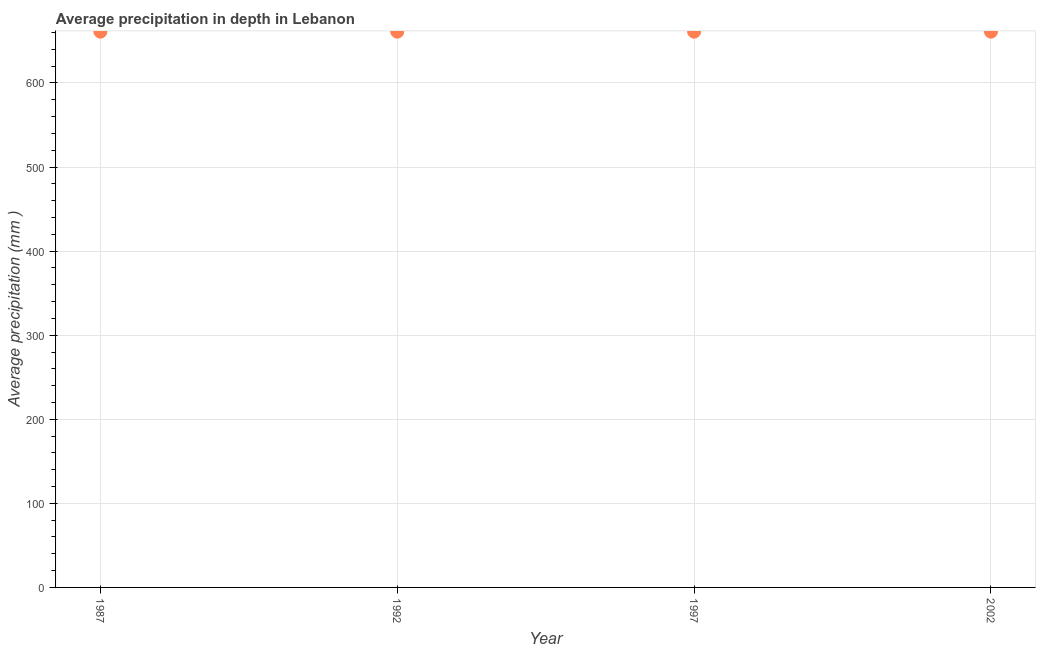What is the average precipitation in depth in 1997?
Your answer should be very brief. 661. Across all years, what is the maximum average precipitation in depth?
Your answer should be compact. 661. Across all years, what is the minimum average precipitation in depth?
Your answer should be very brief. 661. In which year was the average precipitation in depth minimum?
Keep it short and to the point. 1987. What is the sum of the average precipitation in depth?
Offer a terse response. 2644. What is the difference between the average precipitation in depth in 1997 and 2002?
Give a very brief answer. 0. What is the average average precipitation in depth per year?
Offer a terse response. 661. What is the median average precipitation in depth?
Offer a terse response. 661. Do a majority of the years between 1987 and 2002 (inclusive) have average precipitation in depth greater than 380 mm?
Keep it short and to the point. Yes. What is the ratio of the average precipitation in depth in 1992 to that in 2002?
Offer a terse response. 1. Is the difference between the average precipitation in depth in 1987 and 2002 greater than the difference between any two years?
Your answer should be very brief. Yes. What is the difference between the highest and the second highest average precipitation in depth?
Make the answer very short. 0. Is the sum of the average precipitation in depth in 1987 and 1992 greater than the maximum average precipitation in depth across all years?
Provide a succinct answer. Yes. In how many years, is the average precipitation in depth greater than the average average precipitation in depth taken over all years?
Provide a short and direct response. 0. How many dotlines are there?
Make the answer very short. 1. Are the values on the major ticks of Y-axis written in scientific E-notation?
Provide a short and direct response. No. Does the graph contain any zero values?
Your answer should be very brief. No. What is the title of the graph?
Provide a succinct answer. Average precipitation in depth in Lebanon. What is the label or title of the Y-axis?
Offer a terse response. Average precipitation (mm ). What is the Average precipitation (mm ) in 1987?
Offer a terse response. 661. What is the Average precipitation (mm ) in 1992?
Keep it short and to the point. 661. What is the Average precipitation (mm ) in 1997?
Make the answer very short. 661. What is the Average precipitation (mm ) in 2002?
Ensure brevity in your answer.  661. What is the difference between the Average precipitation (mm ) in 1992 and 1997?
Your answer should be compact. 0. What is the difference between the Average precipitation (mm ) in 1992 and 2002?
Your answer should be very brief. 0. What is the difference between the Average precipitation (mm ) in 1997 and 2002?
Provide a short and direct response. 0. What is the ratio of the Average precipitation (mm ) in 1987 to that in 1997?
Your answer should be very brief. 1. What is the ratio of the Average precipitation (mm ) in 1987 to that in 2002?
Provide a succinct answer. 1. What is the ratio of the Average precipitation (mm ) in 1992 to that in 2002?
Keep it short and to the point. 1. 